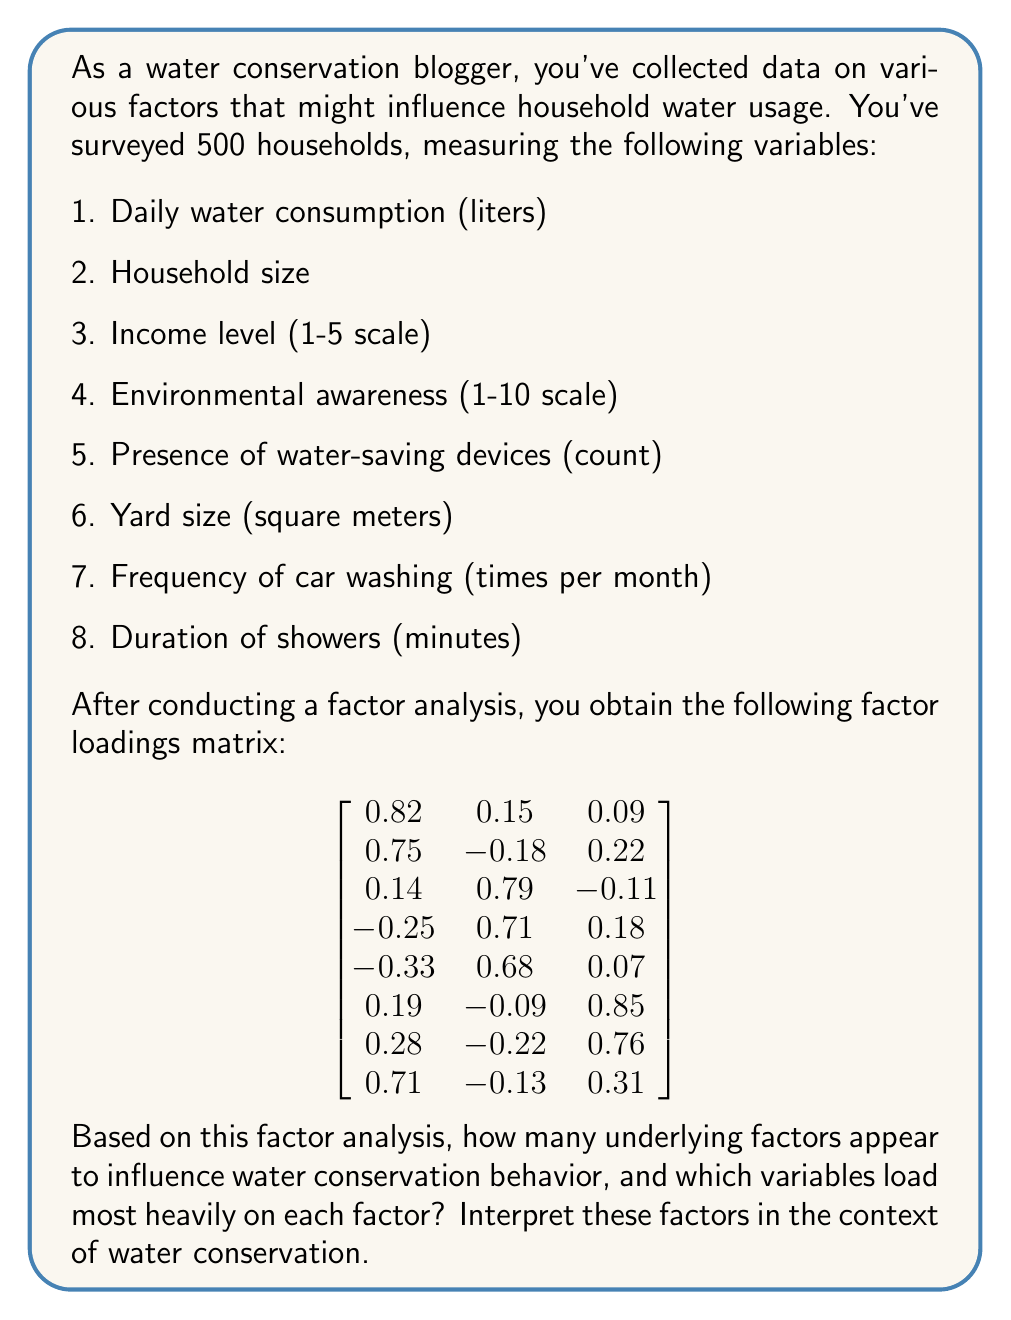Can you solve this math problem? To answer this question, we need to analyze the factor loadings matrix and interpret the results. Let's go through this step-by-step:

1. Number of factors:
   The factor loadings matrix has three columns, indicating that three underlying factors were identified in the analysis.

2. Identifying significant loadings:
   Generally, factor loadings above 0.5 or below -0.5 are considered significant. We'll use this threshold to determine which variables load heavily on each factor.

3. Analyzing each factor:

   Factor 1:
   - Daily water consumption (0.82)
   - Household size (0.75)
   - Duration of showers (0.71)

   Factor 2:
   - Income level (0.79)
   - Environmental awareness (0.71)
   - Presence of water-saving devices (0.68)

   Factor 3:
   - Yard size (0.85)
   - Frequency of car washing (0.76)

4. Interpreting the factors:

   Factor 1: This factor seems to represent "Household Water Usage Patterns." It includes variables directly related to water consumption, such as daily water use, household size, and shower duration.

   Factor 2: This factor appears to represent "Environmental Consciousness and Economic Status." It includes variables related to awareness, income, and the presence of water-saving devices, suggesting a link between economic means and environmental choices.

   Factor 3: This factor can be interpreted as "Outdoor Water Usage." It includes variables related to outdoor activities that consume water, such as yard maintenance and car washing.

5. Importance for water conservation:
   These factors provide insights into the main areas where water conservation efforts could be focused:
   - Targeting household usage patterns (Factor 1)
   - Promoting environmental awareness and water-saving technologies (Factor 2)
   - Addressing outdoor water use (Factor 3)
Answer: The factor analysis reveals three underlying factors influencing water conservation behavior:

1. Household Water Usage Patterns (Factor 1): loads heavily on daily water consumption, household size, and shower duration.
2. Environmental Consciousness and Economic Status (Factor 2): loads heavily on income level, environmental awareness, and presence of water-saving devices.
3. Outdoor Water Usage (Factor 3): loads heavily on yard size and frequency of car washing.

These factors suggest that water conservation efforts should focus on household consumption patterns, promoting environmental awareness and water-saving technologies, and addressing outdoor water use. 